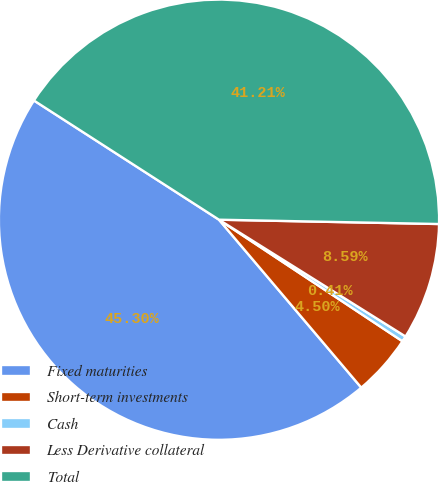Convert chart. <chart><loc_0><loc_0><loc_500><loc_500><pie_chart><fcel>Fixed maturities<fcel>Short-term investments<fcel>Cash<fcel>Less Derivative collateral<fcel>Total<nl><fcel>45.3%<fcel>4.5%<fcel>0.41%<fcel>8.59%<fcel>41.21%<nl></chart> 